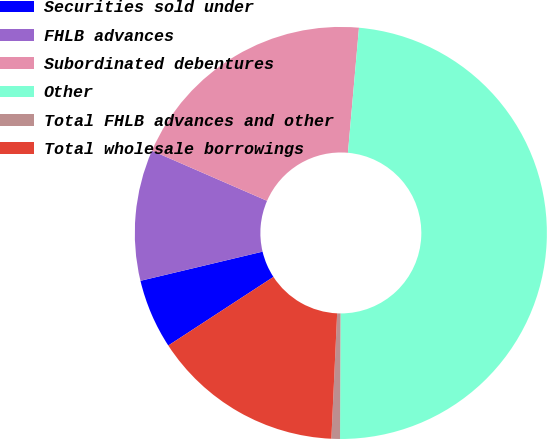Convert chart to OTSL. <chart><loc_0><loc_0><loc_500><loc_500><pie_chart><fcel>Securities sold under<fcel>FHLB advances<fcel>Subordinated debentures<fcel>Other<fcel>Total FHLB advances and other<fcel>Total wholesale borrowings<nl><fcel>5.47%<fcel>10.27%<fcel>19.87%<fcel>48.67%<fcel>0.67%<fcel>15.07%<nl></chart> 